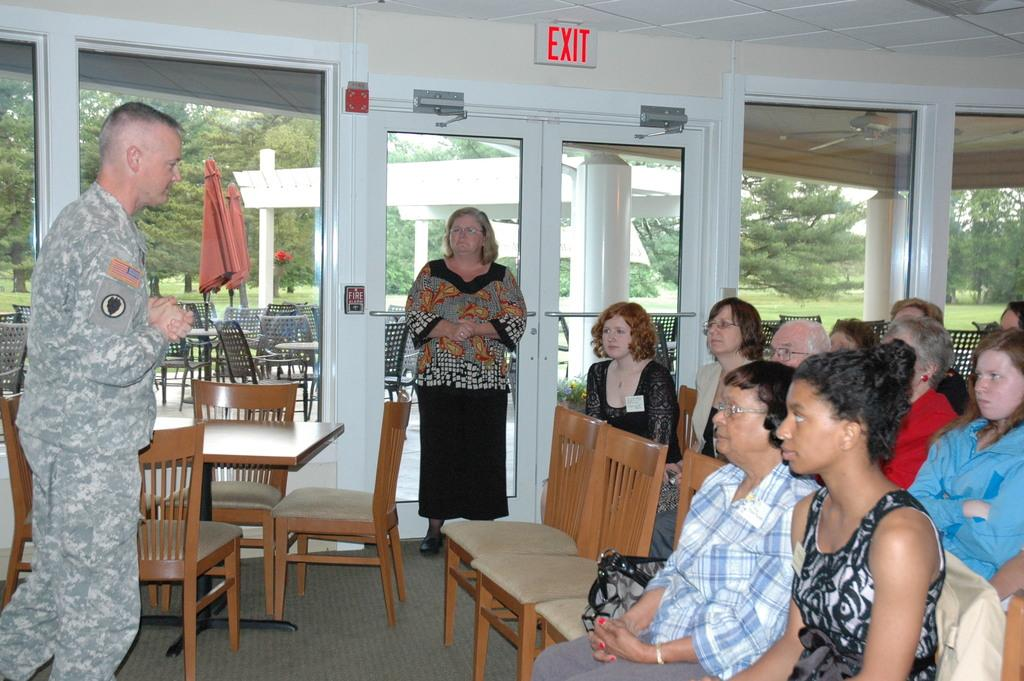What are the people in the image doing? There are people sitting on chairs in the image. Are there any people standing in the image? Yes, there are two people standing in the image. What word is written at the top of the image? The word "EXIT" is written at the top of the image. Can you hear the bell ringing in the image? There is no bell present in the image, so it cannot be heard. 